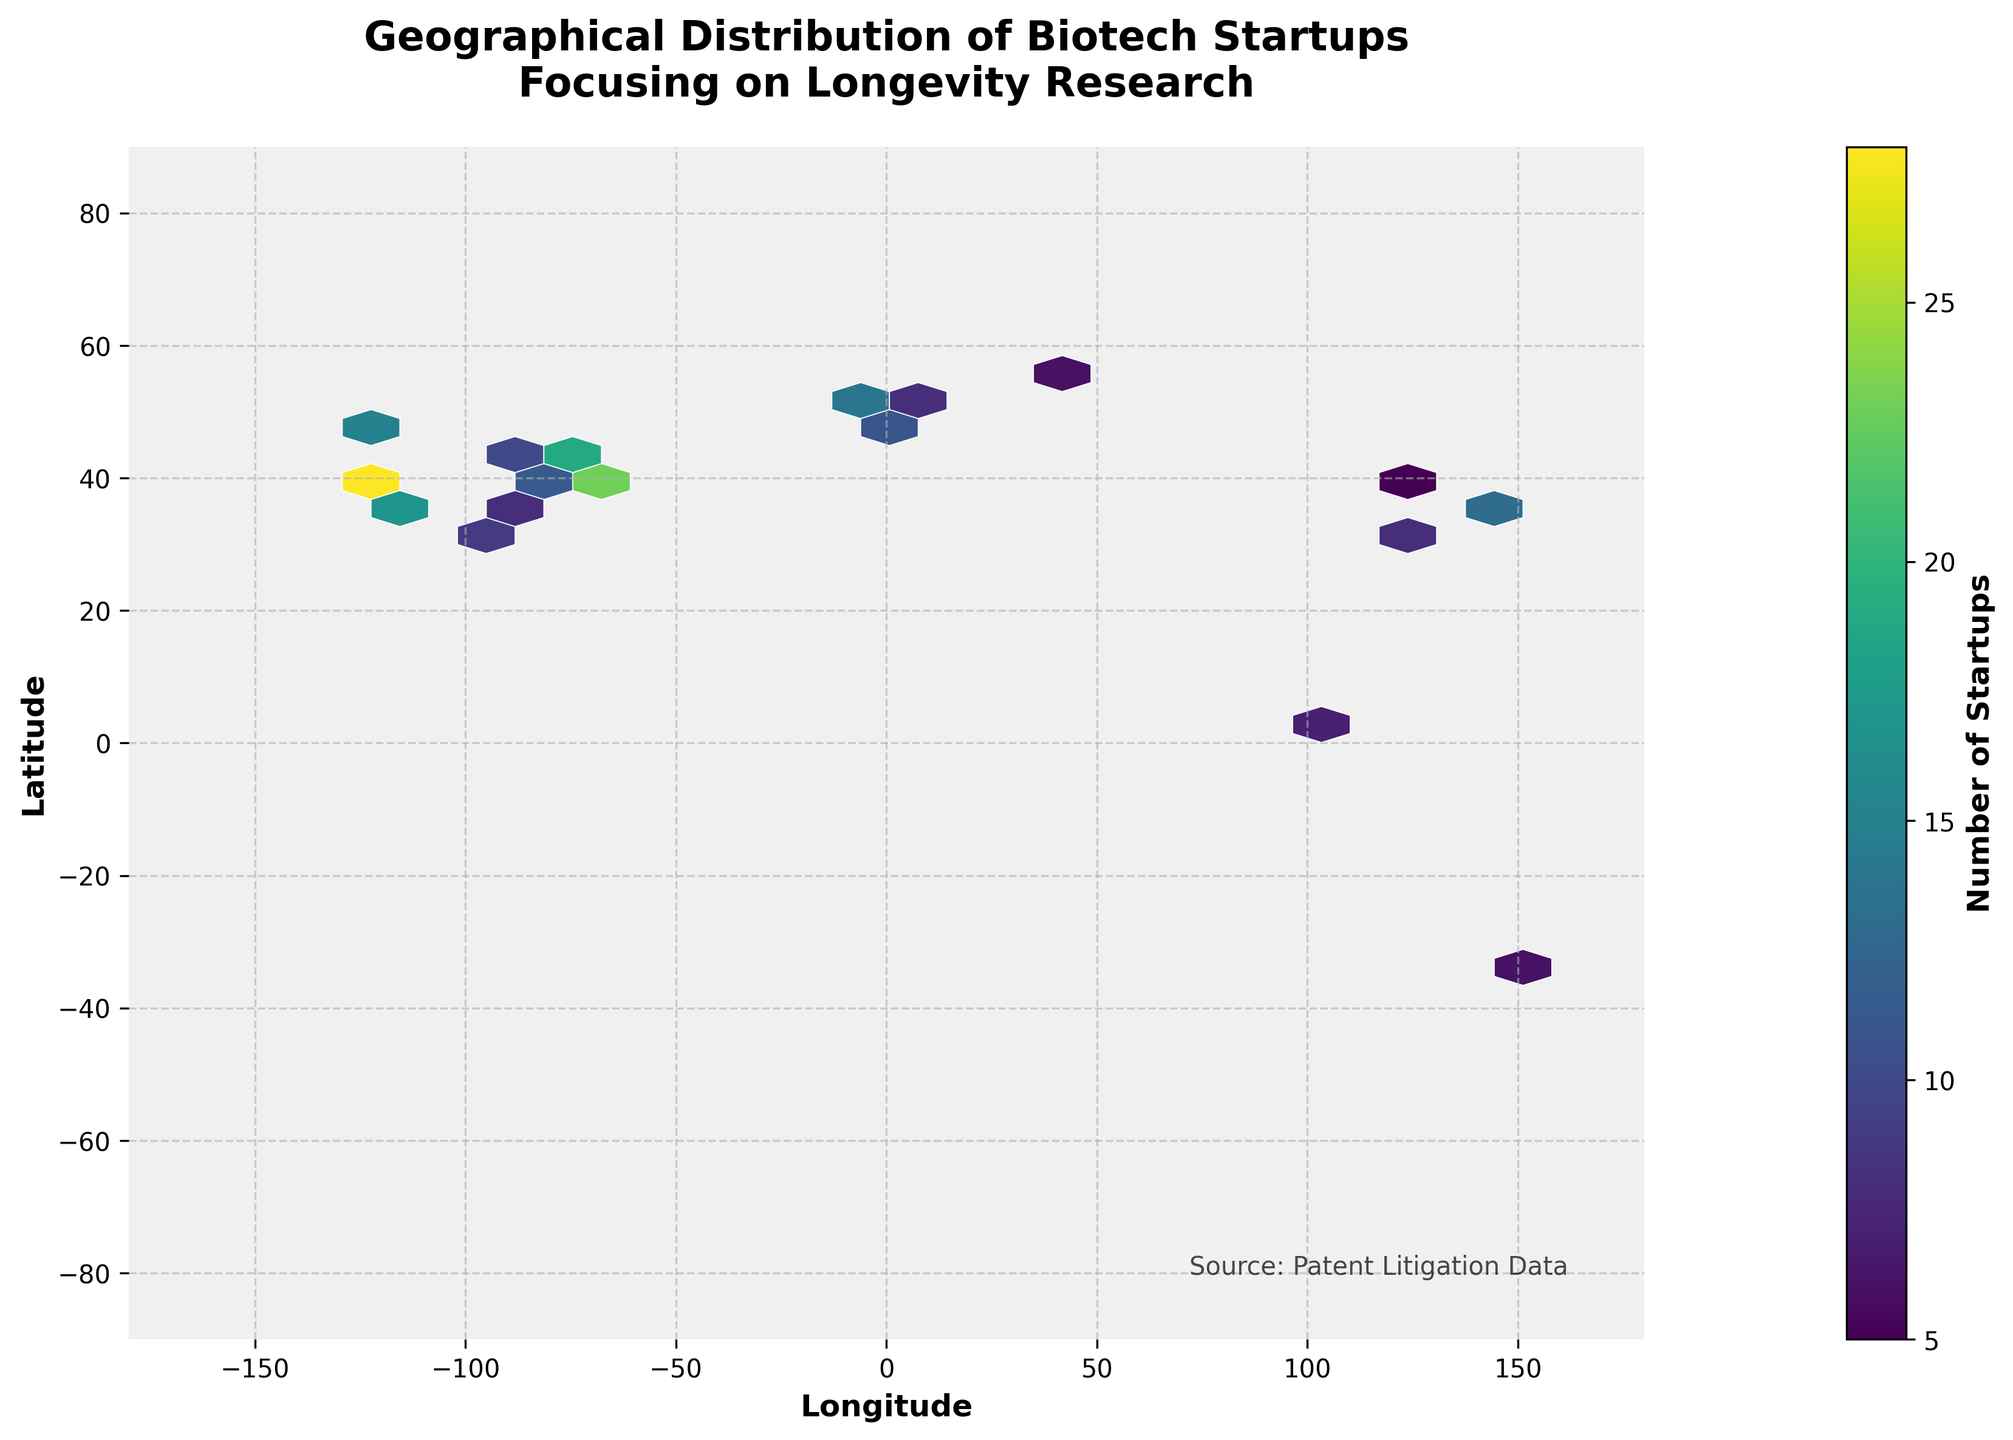What's the title of the plot? The title of the plot is written on the top and is usually the largest text in the figure. In this case, it reads, "Geographical Distribution of Biotech Startups Focusing on Longevity Research".
Answer: Geographical Distribution of Biotech Startups Focusing on Longevity Research What are the units on the color bar? The color bar on the right side of the plot is labeled, "Number of Startups," which indicates that it represents the count of biotech startups.
Answer: Number of Startups What range of longitudes is covered in the plot? The x-axis label "Longitude" shows a range from -180 to 180, covering the full span of longitudinal coordinates.
Answer: -180 to 180 Which latitude and longitude grid cell has the highest concentration of startups? The color intensity in a hexbin plot signifies concentration. The cell with the darkest shade (in this case, the most vivid color on the viridis palette) indicates the highest concentration. From visual inspection, it's near coordinates with San Francisco (37.7749, -122.4194).
Answer: Near San Francisco (37.7749, -122.4194) What is the most common range for startup numbers in this plot? By observing the color bar, the most common color shades on the plot correspond to lighter shades, which are labeled to represent startup numbers between 5 and 10.
Answer: 5 to 10 How does the number of startups in London compare to Tokyo? The color of the hexbin plot over London relates to the color bar value, indicating 14 startups, while the color over Tokyo corresponds to 13 startups.
Answer: London has one more startup than Tokyo Identify two regions that have a similar concentration of startups. By matching the colors on the hexbin plot to the color bar, regions such as Berlin (9 startups) and Austin (9 startups) share a similar concentration of startups.
Answer: Berlin and Austin How does the distribution of biotech startups appear around the latitude of 40°N? Observing the hexbin plot around the 40°N latitude area, notably cities like New York and Boston show concentrated areas of startups. This latitude band appears to have a higher density of startups.
Answer: Higher density of startups around 40°N What's the difference in the number of startups between Los Angeles and Moscow? From examining the color intensity, Los Angeles is represented by 17 startups and Moscow by 6 startups. The difference is calculated as 17 - 6.
Answer: 11 What general pattern can be seen concerning startup locations and continents? Analyzing the hexbin plot, the startups are predominantly concentrated in North America, Europe, and parts of Asia. Comparing the colors, fewer startups are seen in the other continents.
Answer: Concentrated in North America, Europe, and parts of Asia 